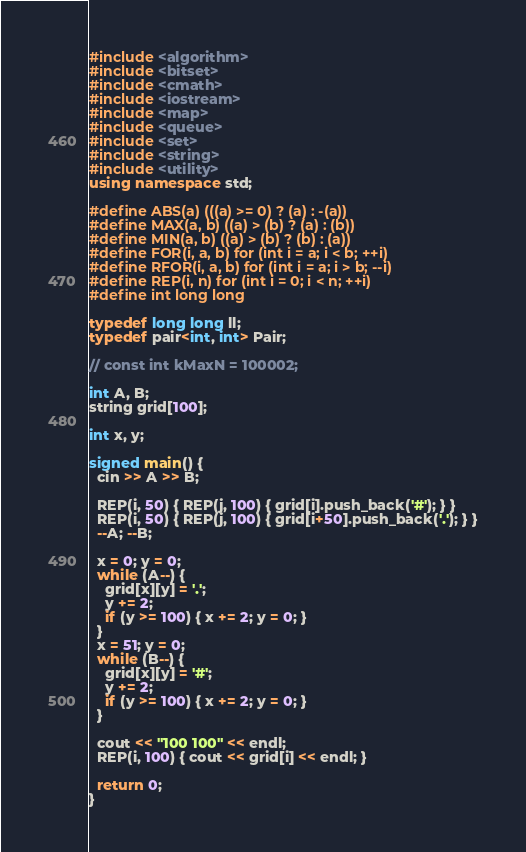Convert code to text. <code><loc_0><loc_0><loc_500><loc_500><_C++_>#include <algorithm>
#include <bitset>
#include <cmath>
#include <iostream>
#include <map>
#include <queue>
#include <set>
#include <string>
#include <utility>
using namespace std;

#define ABS(a) (((a) >= 0) ? (a) : -(a))
#define MAX(a, b) ((a) > (b) ? (a) : (b))
#define MIN(a, b) ((a) > (b) ? (b) : (a))
#define FOR(i, a, b) for (int i = a; i < b; ++i)
#define RFOR(i, a, b) for (int i = a; i > b; --i)
#define REP(i, n) for (int i = 0; i < n; ++i)
#define int long long

typedef long long ll;
typedef pair<int, int> Pair;

// const int kMaxN = 100002;

int A, B;
string grid[100];

int x, y;

signed main() {
  cin >> A >> B;

  REP(i, 50) { REP(j, 100) { grid[i].push_back('#'); } }
  REP(i, 50) { REP(j, 100) { grid[i+50].push_back('.'); } }
  --A; --B;

  x = 0; y = 0;
  while (A--) {
    grid[x][y] = '.';
    y += 2;
    if (y >= 100) { x += 2; y = 0; }
  }
  x = 51; y = 0;
  while (B--) {
    grid[x][y] = '#';
    y += 2;
    if (y >= 100) { x += 2; y = 0; }
  }

  cout << "100 100" << endl;
  REP(i, 100) { cout << grid[i] << endl; }

  return 0;
}
</code> 